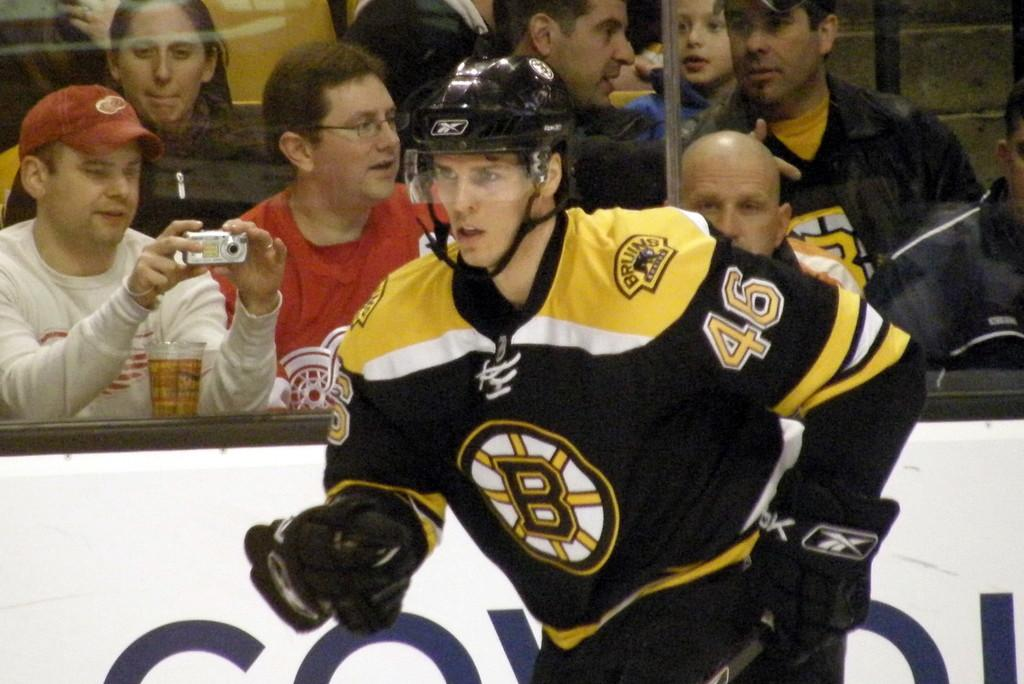<image>
Write a terse but informative summary of the picture. A Bruins hockey player rushes along the barrier of the rink. 